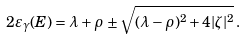<formula> <loc_0><loc_0><loc_500><loc_500>2 \varepsilon _ { \gamma } ( E ) = \lambda + \rho \, \pm \sqrt { ( \lambda - \rho ) ^ { 2 } + 4 | \zeta | ^ { 2 } } \, .</formula> 